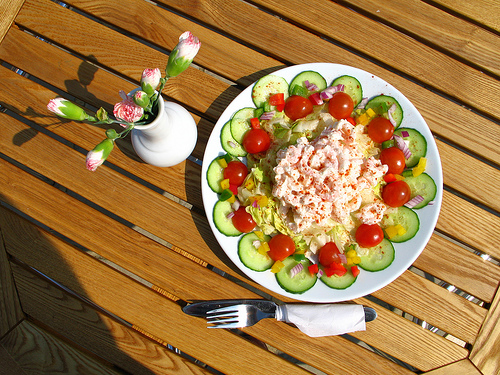<image>
Can you confirm if the flower vase is next to the salad? Yes. The flower vase is positioned adjacent to the salad, located nearby in the same general area. 